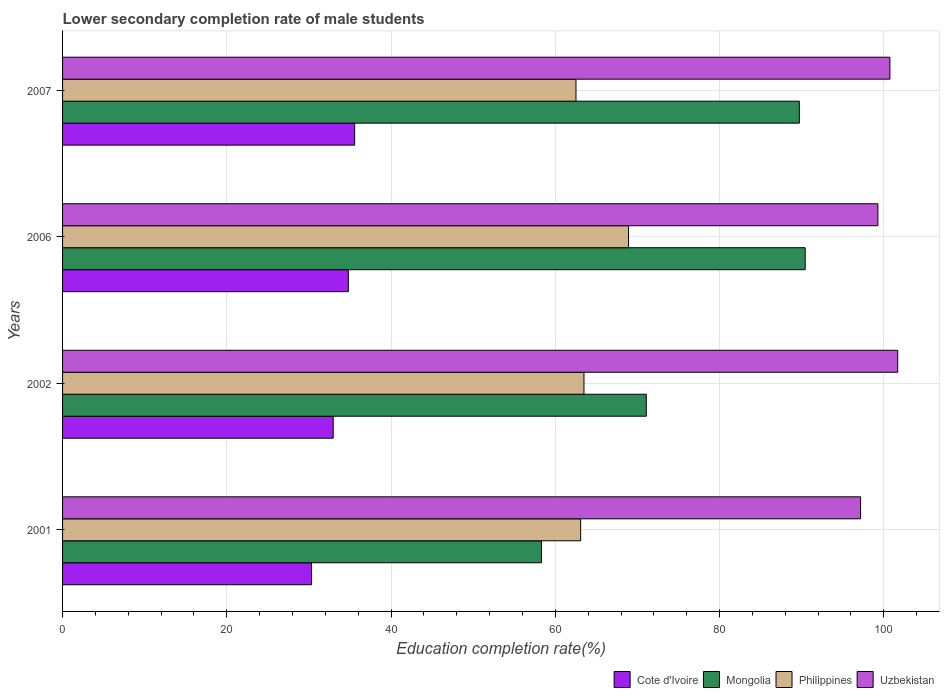How many different coloured bars are there?
Offer a terse response. 4. How many bars are there on the 1st tick from the bottom?
Keep it short and to the point. 4. In how many cases, is the number of bars for a given year not equal to the number of legend labels?
Provide a short and direct response. 0. What is the lower secondary completion rate of male students in Uzbekistan in 2001?
Offer a terse response. 97.17. Across all years, what is the maximum lower secondary completion rate of male students in Mongolia?
Offer a very short reply. 90.43. Across all years, what is the minimum lower secondary completion rate of male students in Philippines?
Provide a short and direct response. 62.52. In which year was the lower secondary completion rate of male students in Philippines minimum?
Your answer should be compact. 2007. What is the total lower secondary completion rate of male students in Philippines in the graph?
Provide a succinct answer. 258. What is the difference between the lower secondary completion rate of male students in Philippines in 2002 and that in 2007?
Offer a very short reply. 0.97. What is the difference between the lower secondary completion rate of male students in Cote d'Ivoire in 2001 and the lower secondary completion rate of male students in Philippines in 2002?
Provide a succinct answer. -33.17. What is the average lower secondary completion rate of male students in Uzbekistan per year?
Keep it short and to the point. 99.72. In the year 2002, what is the difference between the lower secondary completion rate of male students in Uzbekistan and lower secondary completion rate of male students in Cote d'Ivoire?
Keep it short and to the point. 68.74. What is the ratio of the lower secondary completion rate of male students in Mongolia in 2001 to that in 2006?
Your answer should be very brief. 0.64. What is the difference between the highest and the second highest lower secondary completion rate of male students in Uzbekistan?
Give a very brief answer. 0.95. What is the difference between the highest and the lowest lower secondary completion rate of male students in Cote d'Ivoire?
Offer a very short reply. 5.25. In how many years, is the lower secondary completion rate of male students in Uzbekistan greater than the average lower secondary completion rate of male students in Uzbekistan taken over all years?
Your response must be concise. 2. Is the sum of the lower secondary completion rate of male students in Cote d'Ivoire in 2001 and 2006 greater than the maximum lower secondary completion rate of male students in Philippines across all years?
Your answer should be very brief. No. Is it the case that in every year, the sum of the lower secondary completion rate of male students in Uzbekistan and lower secondary completion rate of male students in Cote d'Ivoire is greater than the sum of lower secondary completion rate of male students in Mongolia and lower secondary completion rate of male students in Philippines?
Provide a short and direct response. Yes. What does the 4th bar from the top in 2006 represents?
Ensure brevity in your answer.  Cote d'Ivoire. Is it the case that in every year, the sum of the lower secondary completion rate of male students in Mongolia and lower secondary completion rate of male students in Cote d'Ivoire is greater than the lower secondary completion rate of male students in Uzbekistan?
Your answer should be compact. No. How many bars are there?
Provide a short and direct response. 16. Are all the bars in the graph horizontal?
Your response must be concise. Yes. What is the difference between two consecutive major ticks on the X-axis?
Provide a succinct answer. 20. Where does the legend appear in the graph?
Your response must be concise. Bottom right. What is the title of the graph?
Provide a succinct answer. Lower secondary completion rate of male students. What is the label or title of the X-axis?
Your answer should be very brief. Education completion rate(%). What is the Education completion rate(%) of Cote d'Ivoire in 2001?
Make the answer very short. 30.31. What is the Education completion rate(%) in Mongolia in 2001?
Keep it short and to the point. 58.31. What is the Education completion rate(%) of Philippines in 2001?
Provide a succinct answer. 63.08. What is the Education completion rate(%) in Uzbekistan in 2001?
Ensure brevity in your answer.  97.17. What is the Education completion rate(%) in Cote d'Ivoire in 2002?
Your answer should be very brief. 32.95. What is the Education completion rate(%) of Mongolia in 2002?
Provide a succinct answer. 71.07. What is the Education completion rate(%) of Philippines in 2002?
Provide a short and direct response. 63.49. What is the Education completion rate(%) of Uzbekistan in 2002?
Your answer should be very brief. 101.69. What is the Education completion rate(%) in Cote d'Ivoire in 2006?
Provide a short and direct response. 34.8. What is the Education completion rate(%) of Mongolia in 2006?
Give a very brief answer. 90.43. What is the Education completion rate(%) of Philippines in 2006?
Provide a short and direct response. 68.91. What is the Education completion rate(%) in Uzbekistan in 2006?
Make the answer very short. 99.27. What is the Education completion rate(%) of Cote d'Ivoire in 2007?
Your answer should be compact. 35.57. What is the Education completion rate(%) of Mongolia in 2007?
Make the answer very short. 89.71. What is the Education completion rate(%) in Philippines in 2007?
Keep it short and to the point. 62.52. What is the Education completion rate(%) of Uzbekistan in 2007?
Make the answer very short. 100.74. Across all years, what is the maximum Education completion rate(%) of Cote d'Ivoire?
Your answer should be compact. 35.57. Across all years, what is the maximum Education completion rate(%) in Mongolia?
Ensure brevity in your answer.  90.43. Across all years, what is the maximum Education completion rate(%) in Philippines?
Keep it short and to the point. 68.91. Across all years, what is the maximum Education completion rate(%) in Uzbekistan?
Offer a very short reply. 101.69. Across all years, what is the minimum Education completion rate(%) in Cote d'Ivoire?
Offer a very short reply. 30.31. Across all years, what is the minimum Education completion rate(%) in Mongolia?
Your answer should be very brief. 58.31. Across all years, what is the minimum Education completion rate(%) in Philippines?
Your answer should be compact. 62.52. Across all years, what is the minimum Education completion rate(%) of Uzbekistan?
Ensure brevity in your answer.  97.17. What is the total Education completion rate(%) in Cote d'Ivoire in the graph?
Give a very brief answer. 133.63. What is the total Education completion rate(%) of Mongolia in the graph?
Offer a terse response. 309.52. What is the total Education completion rate(%) in Philippines in the graph?
Keep it short and to the point. 258. What is the total Education completion rate(%) in Uzbekistan in the graph?
Offer a terse response. 398.87. What is the difference between the Education completion rate(%) in Cote d'Ivoire in 2001 and that in 2002?
Make the answer very short. -2.64. What is the difference between the Education completion rate(%) in Mongolia in 2001 and that in 2002?
Your answer should be very brief. -12.77. What is the difference between the Education completion rate(%) in Philippines in 2001 and that in 2002?
Provide a short and direct response. -0.4. What is the difference between the Education completion rate(%) of Uzbekistan in 2001 and that in 2002?
Offer a terse response. -4.52. What is the difference between the Education completion rate(%) of Cote d'Ivoire in 2001 and that in 2006?
Make the answer very short. -4.48. What is the difference between the Education completion rate(%) in Mongolia in 2001 and that in 2006?
Offer a very short reply. -32.12. What is the difference between the Education completion rate(%) of Philippines in 2001 and that in 2006?
Provide a succinct answer. -5.83. What is the difference between the Education completion rate(%) of Uzbekistan in 2001 and that in 2006?
Offer a terse response. -2.11. What is the difference between the Education completion rate(%) of Cote d'Ivoire in 2001 and that in 2007?
Your response must be concise. -5.25. What is the difference between the Education completion rate(%) in Mongolia in 2001 and that in 2007?
Your answer should be compact. -31.4. What is the difference between the Education completion rate(%) of Philippines in 2001 and that in 2007?
Your answer should be very brief. 0.57. What is the difference between the Education completion rate(%) in Uzbekistan in 2001 and that in 2007?
Your answer should be very brief. -3.57. What is the difference between the Education completion rate(%) of Cote d'Ivoire in 2002 and that in 2006?
Your response must be concise. -1.84. What is the difference between the Education completion rate(%) in Mongolia in 2002 and that in 2006?
Ensure brevity in your answer.  -19.35. What is the difference between the Education completion rate(%) in Philippines in 2002 and that in 2006?
Offer a terse response. -5.43. What is the difference between the Education completion rate(%) of Uzbekistan in 2002 and that in 2006?
Ensure brevity in your answer.  2.42. What is the difference between the Education completion rate(%) in Cote d'Ivoire in 2002 and that in 2007?
Provide a succinct answer. -2.61. What is the difference between the Education completion rate(%) of Mongolia in 2002 and that in 2007?
Offer a very short reply. -18.64. What is the difference between the Education completion rate(%) of Philippines in 2002 and that in 2007?
Your answer should be very brief. 0.97. What is the difference between the Education completion rate(%) in Uzbekistan in 2002 and that in 2007?
Keep it short and to the point. 0.95. What is the difference between the Education completion rate(%) in Cote d'Ivoire in 2006 and that in 2007?
Your answer should be very brief. -0.77. What is the difference between the Education completion rate(%) of Mongolia in 2006 and that in 2007?
Offer a terse response. 0.71. What is the difference between the Education completion rate(%) in Philippines in 2006 and that in 2007?
Your response must be concise. 6.4. What is the difference between the Education completion rate(%) in Uzbekistan in 2006 and that in 2007?
Give a very brief answer. -1.46. What is the difference between the Education completion rate(%) of Cote d'Ivoire in 2001 and the Education completion rate(%) of Mongolia in 2002?
Provide a short and direct response. -40.76. What is the difference between the Education completion rate(%) in Cote d'Ivoire in 2001 and the Education completion rate(%) in Philippines in 2002?
Offer a very short reply. -33.17. What is the difference between the Education completion rate(%) in Cote d'Ivoire in 2001 and the Education completion rate(%) in Uzbekistan in 2002?
Make the answer very short. -71.38. What is the difference between the Education completion rate(%) of Mongolia in 2001 and the Education completion rate(%) of Philippines in 2002?
Your answer should be very brief. -5.18. What is the difference between the Education completion rate(%) in Mongolia in 2001 and the Education completion rate(%) in Uzbekistan in 2002?
Your response must be concise. -43.38. What is the difference between the Education completion rate(%) in Philippines in 2001 and the Education completion rate(%) in Uzbekistan in 2002?
Provide a short and direct response. -38.61. What is the difference between the Education completion rate(%) in Cote d'Ivoire in 2001 and the Education completion rate(%) in Mongolia in 2006?
Your answer should be compact. -60.11. What is the difference between the Education completion rate(%) of Cote d'Ivoire in 2001 and the Education completion rate(%) of Philippines in 2006?
Your response must be concise. -38.6. What is the difference between the Education completion rate(%) of Cote d'Ivoire in 2001 and the Education completion rate(%) of Uzbekistan in 2006?
Keep it short and to the point. -68.96. What is the difference between the Education completion rate(%) of Mongolia in 2001 and the Education completion rate(%) of Philippines in 2006?
Give a very brief answer. -10.6. What is the difference between the Education completion rate(%) of Mongolia in 2001 and the Education completion rate(%) of Uzbekistan in 2006?
Provide a succinct answer. -40.97. What is the difference between the Education completion rate(%) of Philippines in 2001 and the Education completion rate(%) of Uzbekistan in 2006?
Give a very brief answer. -36.19. What is the difference between the Education completion rate(%) of Cote d'Ivoire in 2001 and the Education completion rate(%) of Mongolia in 2007?
Your answer should be very brief. -59.4. What is the difference between the Education completion rate(%) of Cote d'Ivoire in 2001 and the Education completion rate(%) of Philippines in 2007?
Your response must be concise. -32.2. What is the difference between the Education completion rate(%) in Cote d'Ivoire in 2001 and the Education completion rate(%) in Uzbekistan in 2007?
Provide a short and direct response. -70.42. What is the difference between the Education completion rate(%) of Mongolia in 2001 and the Education completion rate(%) of Philippines in 2007?
Offer a very short reply. -4.21. What is the difference between the Education completion rate(%) in Mongolia in 2001 and the Education completion rate(%) in Uzbekistan in 2007?
Give a very brief answer. -42.43. What is the difference between the Education completion rate(%) in Philippines in 2001 and the Education completion rate(%) in Uzbekistan in 2007?
Ensure brevity in your answer.  -37.65. What is the difference between the Education completion rate(%) in Cote d'Ivoire in 2002 and the Education completion rate(%) in Mongolia in 2006?
Your response must be concise. -57.47. What is the difference between the Education completion rate(%) in Cote d'Ivoire in 2002 and the Education completion rate(%) in Philippines in 2006?
Give a very brief answer. -35.96. What is the difference between the Education completion rate(%) of Cote d'Ivoire in 2002 and the Education completion rate(%) of Uzbekistan in 2006?
Make the answer very short. -66.32. What is the difference between the Education completion rate(%) in Mongolia in 2002 and the Education completion rate(%) in Philippines in 2006?
Your answer should be very brief. 2.16. What is the difference between the Education completion rate(%) in Mongolia in 2002 and the Education completion rate(%) in Uzbekistan in 2006?
Your answer should be compact. -28.2. What is the difference between the Education completion rate(%) of Philippines in 2002 and the Education completion rate(%) of Uzbekistan in 2006?
Ensure brevity in your answer.  -35.79. What is the difference between the Education completion rate(%) in Cote d'Ivoire in 2002 and the Education completion rate(%) in Mongolia in 2007?
Offer a terse response. -56.76. What is the difference between the Education completion rate(%) in Cote d'Ivoire in 2002 and the Education completion rate(%) in Philippines in 2007?
Give a very brief answer. -29.56. What is the difference between the Education completion rate(%) in Cote d'Ivoire in 2002 and the Education completion rate(%) in Uzbekistan in 2007?
Ensure brevity in your answer.  -67.78. What is the difference between the Education completion rate(%) of Mongolia in 2002 and the Education completion rate(%) of Philippines in 2007?
Offer a very short reply. 8.56. What is the difference between the Education completion rate(%) in Mongolia in 2002 and the Education completion rate(%) in Uzbekistan in 2007?
Your answer should be very brief. -29.66. What is the difference between the Education completion rate(%) in Philippines in 2002 and the Education completion rate(%) in Uzbekistan in 2007?
Your response must be concise. -37.25. What is the difference between the Education completion rate(%) in Cote d'Ivoire in 2006 and the Education completion rate(%) in Mongolia in 2007?
Make the answer very short. -54.92. What is the difference between the Education completion rate(%) of Cote d'Ivoire in 2006 and the Education completion rate(%) of Philippines in 2007?
Provide a succinct answer. -27.72. What is the difference between the Education completion rate(%) of Cote d'Ivoire in 2006 and the Education completion rate(%) of Uzbekistan in 2007?
Ensure brevity in your answer.  -65.94. What is the difference between the Education completion rate(%) in Mongolia in 2006 and the Education completion rate(%) in Philippines in 2007?
Provide a short and direct response. 27.91. What is the difference between the Education completion rate(%) of Mongolia in 2006 and the Education completion rate(%) of Uzbekistan in 2007?
Offer a terse response. -10.31. What is the difference between the Education completion rate(%) of Philippines in 2006 and the Education completion rate(%) of Uzbekistan in 2007?
Your answer should be compact. -31.82. What is the average Education completion rate(%) in Cote d'Ivoire per year?
Give a very brief answer. 33.41. What is the average Education completion rate(%) of Mongolia per year?
Offer a very short reply. 77.38. What is the average Education completion rate(%) in Philippines per year?
Make the answer very short. 64.5. What is the average Education completion rate(%) in Uzbekistan per year?
Your answer should be very brief. 99.72. In the year 2001, what is the difference between the Education completion rate(%) in Cote d'Ivoire and Education completion rate(%) in Mongolia?
Offer a very short reply. -27.99. In the year 2001, what is the difference between the Education completion rate(%) in Cote d'Ivoire and Education completion rate(%) in Philippines?
Offer a terse response. -32.77. In the year 2001, what is the difference between the Education completion rate(%) of Cote d'Ivoire and Education completion rate(%) of Uzbekistan?
Your response must be concise. -66.85. In the year 2001, what is the difference between the Education completion rate(%) of Mongolia and Education completion rate(%) of Philippines?
Your response must be concise. -4.78. In the year 2001, what is the difference between the Education completion rate(%) in Mongolia and Education completion rate(%) in Uzbekistan?
Ensure brevity in your answer.  -38.86. In the year 2001, what is the difference between the Education completion rate(%) in Philippines and Education completion rate(%) in Uzbekistan?
Provide a short and direct response. -34.08. In the year 2002, what is the difference between the Education completion rate(%) in Cote d'Ivoire and Education completion rate(%) in Mongolia?
Your answer should be very brief. -38.12. In the year 2002, what is the difference between the Education completion rate(%) of Cote d'Ivoire and Education completion rate(%) of Philippines?
Your answer should be very brief. -30.53. In the year 2002, what is the difference between the Education completion rate(%) of Cote d'Ivoire and Education completion rate(%) of Uzbekistan?
Ensure brevity in your answer.  -68.74. In the year 2002, what is the difference between the Education completion rate(%) in Mongolia and Education completion rate(%) in Philippines?
Offer a very short reply. 7.59. In the year 2002, what is the difference between the Education completion rate(%) in Mongolia and Education completion rate(%) in Uzbekistan?
Give a very brief answer. -30.62. In the year 2002, what is the difference between the Education completion rate(%) in Philippines and Education completion rate(%) in Uzbekistan?
Your answer should be very brief. -38.21. In the year 2006, what is the difference between the Education completion rate(%) of Cote d'Ivoire and Education completion rate(%) of Mongolia?
Your answer should be compact. -55.63. In the year 2006, what is the difference between the Education completion rate(%) in Cote d'Ivoire and Education completion rate(%) in Philippines?
Ensure brevity in your answer.  -34.12. In the year 2006, what is the difference between the Education completion rate(%) in Cote d'Ivoire and Education completion rate(%) in Uzbekistan?
Provide a short and direct response. -64.48. In the year 2006, what is the difference between the Education completion rate(%) of Mongolia and Education completion rate(%) of Philippines?
Give a very brief answer. 21.51. In the year 2006, what is the difference between the Education completion rate(%) in Mongolia and Education completion rate(%) in Uzbekistan?
Your answer should be very brief. -8.85. In the year 2006, what is the difference between the Education completion rate(%) in Philippines and Education completion rate(%) in Uzbekistan?
Make the answer very short. -30.36. In the year 2007, what is the difference between the Education completion rate(%) in Cote d'Ivoire and Education completion rate(%) in Mongolia?
Your answer should be very brief. -54.14. In the year 2007, what is the difference between the Education completion rate(%) of Cote d'Ivoire and Education completion rate(%) of Philippines?
Make the answer very short. -26.95. In the year 2007, what is the difference between the Education completion rate(%) in Cote d'Ivoire and Education completion rate(%) in Uzbekistan?
Give a very brief answer. -65.17. In the year 2007, what is the difference between the Education completion rate(%) in Mongolia and Education completion rate(%) in Philippines?
Your answer should be compact. 27.2. In the year 2007, what is the difference between the Education completion rate(%) in Mongolia and Education completion rate(%) in Uzbekistan?
Offer a very short reply. -11.02. In the year 2007, what is the difference between the Education completion rate(%) in Philippines and Education completion rate(%) in Uzbekistan?
Your answer should be compact. -38.22. What is the ratio of the Education completion rate(%) in Cote d'Ivoire in 2001 to that in 2002?
Provide a short and direct response. 0.92. What is the ratio of the Education completion rate(%) in Mongolia in 2001 to that in 2002?
Give a very brief answer. 0.82. What is the ratio of the Education completion rate(%) in Philippines in 2001 to that in 2002?
Offer a terse response. 0.99. What is the ratio of the Education completion rate(%) of Uzbekistan in 2001 to that in 2002?
Give a very brief answer. 0.96. What is the ratio of the Education completion rate(%) of Cote d'Ivoire in 2001 to that in 2006?
Your response must be concise. 0.87. What is the ratio of the Education completion rate(%) in Mongolia in 2001 to that in 2006?
Give a very brief answer. 0.64. What is the ratio of the Education completion rate(%) in Philippines in 2001 to that in 2006?
Your response must be concise. 0.92. What is the ratio of the Education completion rate(%) of Uzbekistan in 2001 to that in 2006?
Your response must be concise. 0.98. What is the ratio of the Education completion rate(%) of Cote d'Ivoire in 2001 to that in 2007?
Your response must be concise. 0.85. What is the ratio of the Education completion rate(%) of Mongolia in 2001 to that in 2007?
Keep it short and to the point. 0.65. What is the ratio of the Education completion rate(%) of Philippines in 2001 to that in 2007?
Keep it short and to the point. 1.01. What is the ratio of the Education completion rate(%) of Uzbekistan in 2001 to that in 2007?
Provide a succinct answer. 0.96. What is the ratio of the Education completion rate(%) of Cote d'Ivoire in 2002 to that in 2006?
Ensure brevity in your answer.  0.95. What is the ratio of the Education completion rate(%) in Mongolia in 2002 to that in 2006?
Keep it short and to the point. 0.79. What is the ratio of the Education completion rate(%) of Philippines in 2002 to that in 2006?
Make the answer very short. 0.92. What is the ratio of the Education completion rate(%) of Uzbekistan in 2002 to that in 2006?
Make the answer very short. 1.02. What is the ratio of the Education completion rate(%) of Cote d'Ivoire in 2002 to that in 2007?
Make the answer very short. 0.93. What is the ratio of the Education completion rate(%) in Mongolia in 2002 to that in 2007?
Keep it short and to the point. 0.79. What is the ratio of the Education completion rate(%) of Philippines in 2002 to that in 2007?
Your answer should be very brief. 1.02. What is the ratio of the Education completion rate(%) of Uzbekistan in 2002 to that in 2007?
Provide a short and direct response. 1.01. What is the ratio of the Education completion rate(%) in Cote d'Ivoire in 2006 to that in 2007?
Provide a succinct answer. 0.98. What is the ratio of the Education completion rate(%) in Mongolia in 2006 to that in 2007?
Offer a terse response. 1.01. What is the ratio of the Education completion rate(%) in Philippines in 2006 to that in 2007?
Provide a short and direct response. 1.1. What is the ratio of the Education completion rate(%) of Uzbekistan in 2006 to that in 2007?
Give a very brief answer. 0.99. What is the difference between the highest and the second highest Education completion rate(%) in Cote d'Ivoire?
Keep it short and to the point. 0.77. What is the difference between the highest and the second highest Education completion rate(%) of Mongolia?
Offer a terse response. 0.71. What is the difference between the highest and the second highest Education completion rate(%) of Philippines?
Your answer should be very brief. 5.43. What is the difference between the highest and the second highest Education completion rate(%) of Uzbekistan?
Give a very brief answer. 0.95. What is the difference between the highest and the lowest Education completion rate(%) of Cote d'Ivoire?
Make the answer very short. 5.25. What is the difference between the highest and the lowest Education completion rate(%) of Mongolia?
Your answer should be compact. 32.12. What is the difference between the highest and the lowest Education completion rate(%) of Philippines?
Offer a terse response. 6.4. What is the difference between the highest and the lowest Education completion rate(%) in Uzbekistan?
Your response must be concise. 4.52. 